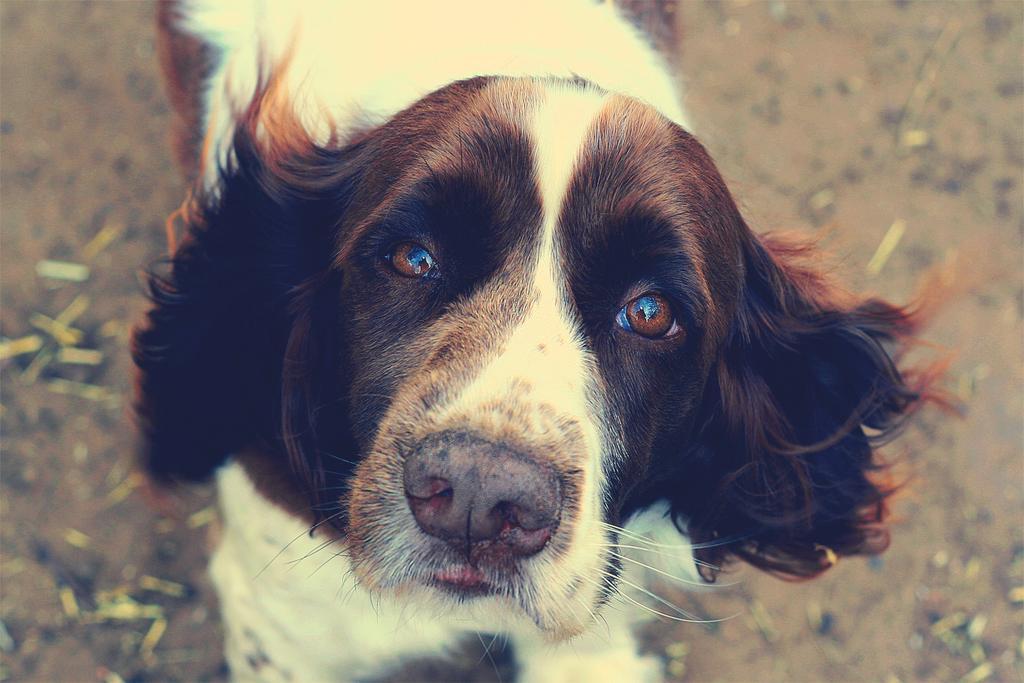Can you describe this image briefly? In this picture there is a white and brown color dog standing and looking into the camera. Behind there is a blur background. 